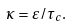Convert formula to latex. <formula><loc_0><loc_0><loc_500><loc_500>\kappa = \varepsilon / \tau _ { c } .</formula> 